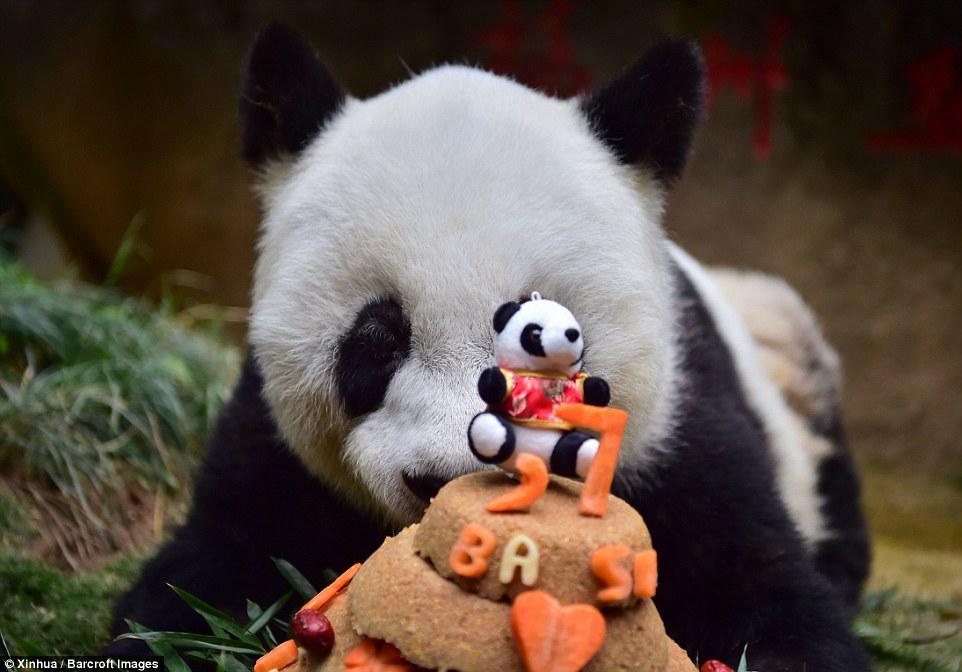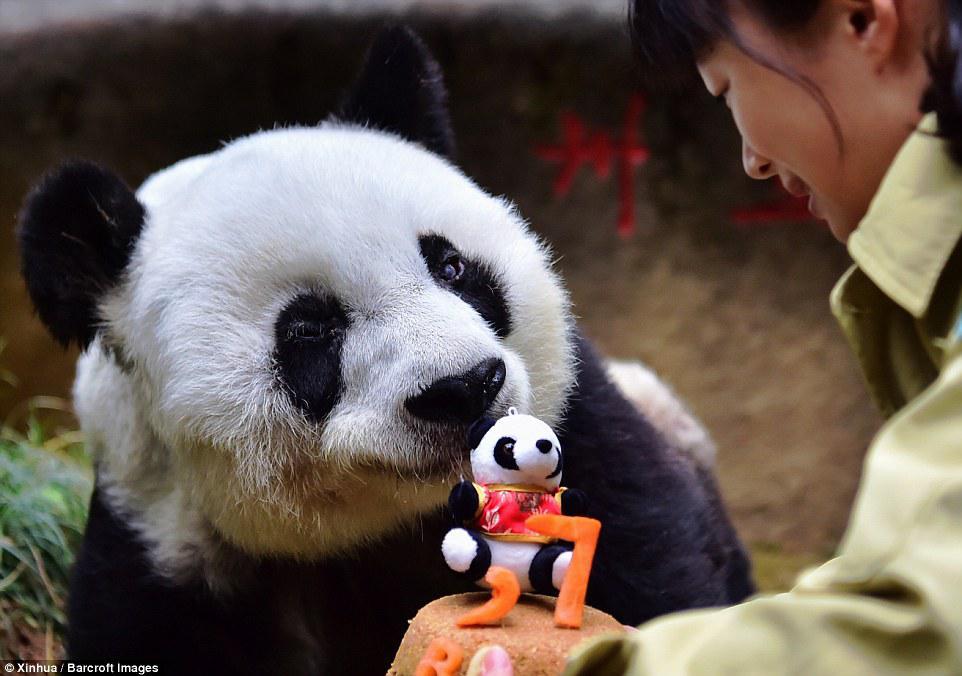The first image is the image on the left, the second image is the image on the right. For the images shown, is this caption "The combined images include a dark-haired woman and a panda wearing a red-and-gold crown." true? Answer yes or no. No. The first image is the image on the left, the second image is the image on the right. Assess this claim about the two images: "The panda in the image on the right is wearing a hat.". Correct or not? Answer yes or no. No. 